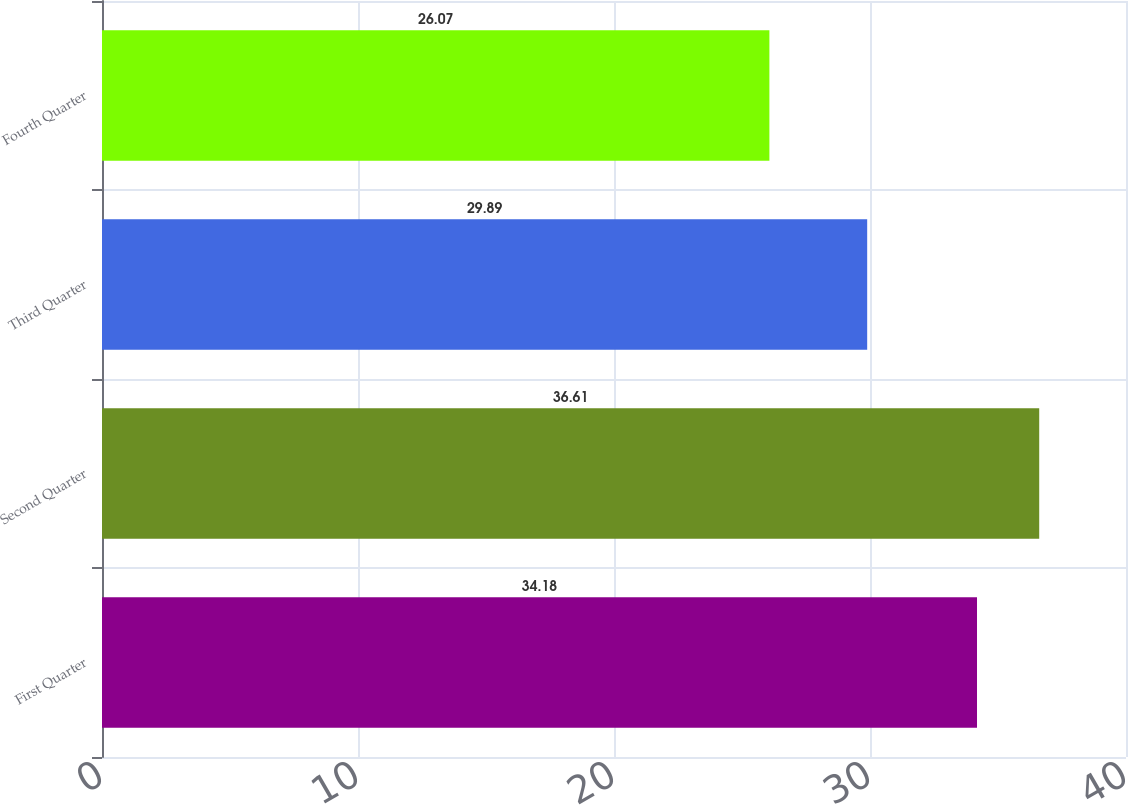Convert chart to OTSL. <chart><loc_0><loc_0><loc_500><loc_500><bar_chart><fcel>First Quarter<fcel>Second Quarter<fcel>Third Quarter<fcel>Fourth Quarter<nl><fcel>34.18<fcel>36.61<fcel>29.89<fcel>26.07<nl></chart> 